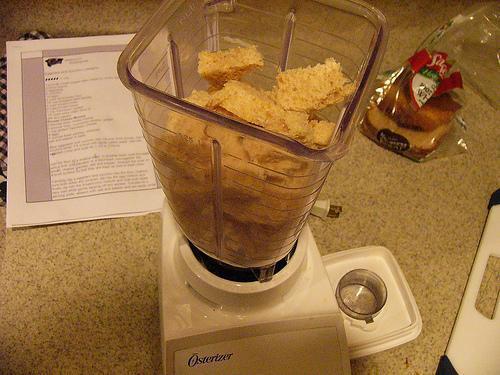How many blenders are in the picture?
Give a very brief answer. 1. 